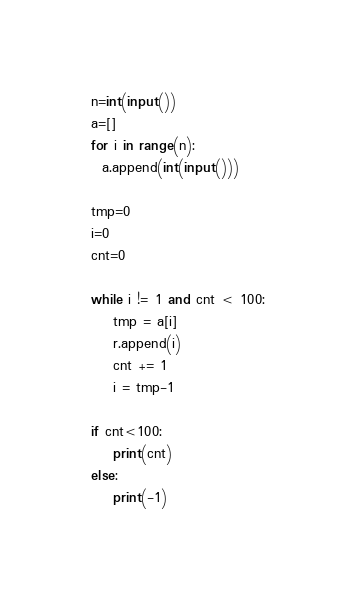Convert code to text. <code><loc_0><loc_0><loc_500><loc_500><_Python_>n=int(input())
a=[]
for i in range(n):
  a.append(int(input()))

tmp=0
i=0
cnt=0

while i != 1 and cnt < 100:
    tmp = a[i]
    r.append(i)
    cnt += 1
    i = tmp-1

if cnt<100:
    print(cnt)
else:
    print(-1)
</code> 